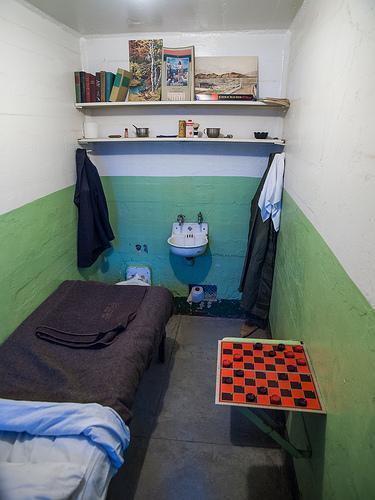How many books are there?
Give a very brief answer. 8. How many towels on the bed?
Give a very brief answer. 1. 